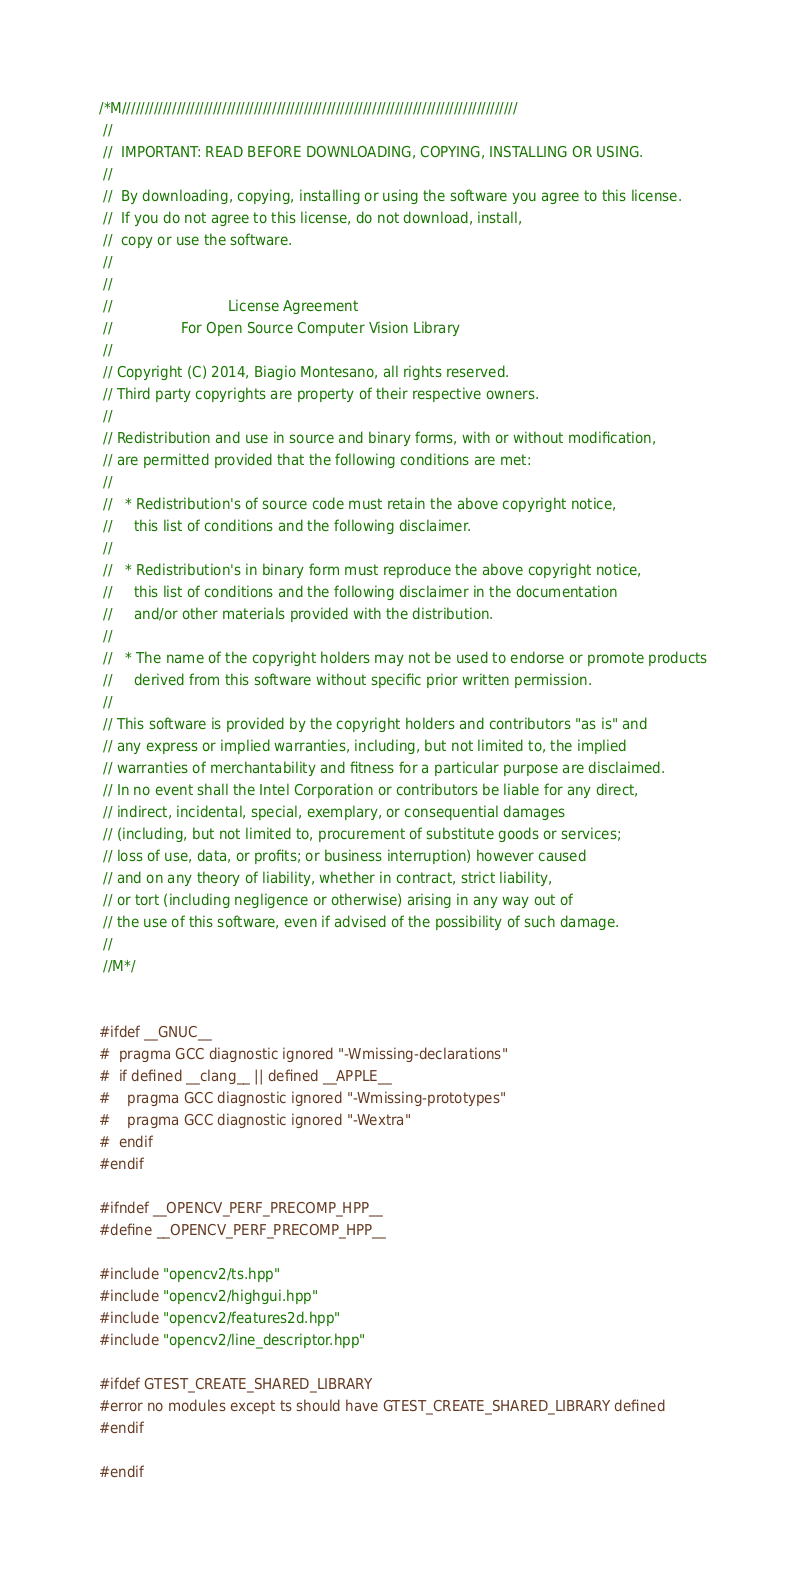Convert code to text. <code><loc_0><loc_0><loc_500><loc_500><_C++_>/*M///////////////////////////////////////////////////////////////////////////////////////
 //
 //  IMPORTANT: READ BEFORE DOWNLOADING, COPYING, INSTALLING OR USING.
 //
 //  By downloading, copying, installing or using the software you agree to this license.
 //  If you do not agree to this license, do not download, install,
 //  copy or use the software.
 //
 //
 //                           License Agreement
 //                For Open Source Computer Vision Library
 //
 // Copyright (C) 2014, Biagio Montesano, all rights reserved.
 // Third party copyrights are property of their respective owners.
 //
 // Redistribution and use in source and binary forms, with or without modification,
 // are permitted provided that the following conditions are met:
 //
 //   * Redistribution's of source code must retain the above copyright notice,
 //     this list of conditions and the following disclaimer.
 //
 //   * Redistribution's in binary form must reproduce the above copyright notice,
 //     this list of conditions and the following disclaimer in the documentation
 //     and/or other materials provided with the distribution.
 //
 //   * The name of the copyright holders may not be used to endorse or promote products
 //     derived from this software without specific prior written permission.
 //
 // This software is provided by the copyright holders and contributors "as is" and
 // any express or implied warranties, including, but not limited to, the implied
 // warranties of merchantability and fitness for a particular purpose are disclaimed.
 // In no event shall the Intel Corporation or contributors be liable for any direct,
 // indirect, incidental, special, exemplary, or consequential damages
 // (including, but not limited to, procurement of substitute goods or services;
 // loss of use, data, or profits; or business interruption) however caused
 // and on any theory of liability, whether in contract, strict liability,
 // or tort (including negligence or otherwise) arising in any way out of
 // the use of this software, even if advised of the possibility of such damage.
 //
 //M*/


#ifdef __GNUC__
#  pragma GCC diagnostic ignored "-Wmissing-declarations"
#  if defined __clang__ || defined __APPLE__
#    pragma GCC diagnostic ignored "-Wmissing-prototypes"
#    pragma GCC diagnostic ignored "-Wextra"
#  endif
#endif

#ifndef __OPENCV_PERF_PRECOMP_HPP__
#define __OPENCV_PERF_PRECOMP_HPP__

#include "opencv2/ts.hpp"
#include "opencv2/highgui.hpp"
#include "opencv2/features2d.hpp"
#include "opencv2/line_descriptor.hpp"

#ifdef GTEST_CREATE_SHARED_LIBRARY
#error no modules except ts should have GTEST_CREATE_SHARED_LIBRARY defined
#endif

#endif
</code> 